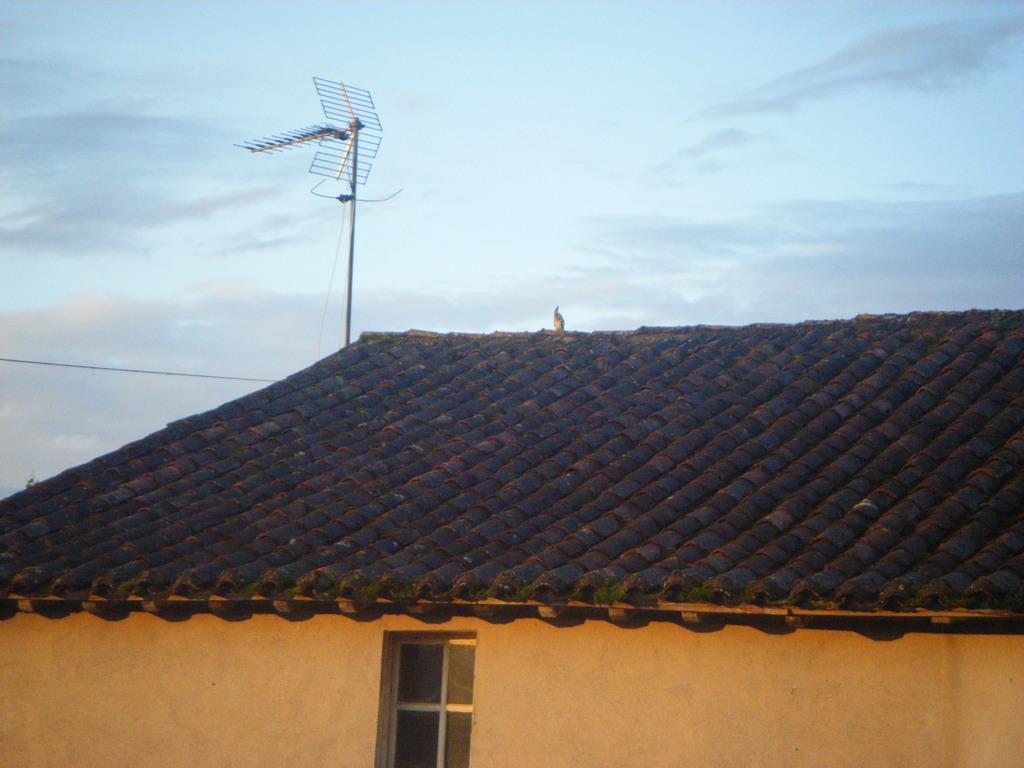How would you summarize this image in a sentence or two? In this picture we can see a pole, wire, roof, wall and window. In the background of the image we can see the clouds in the sky. 